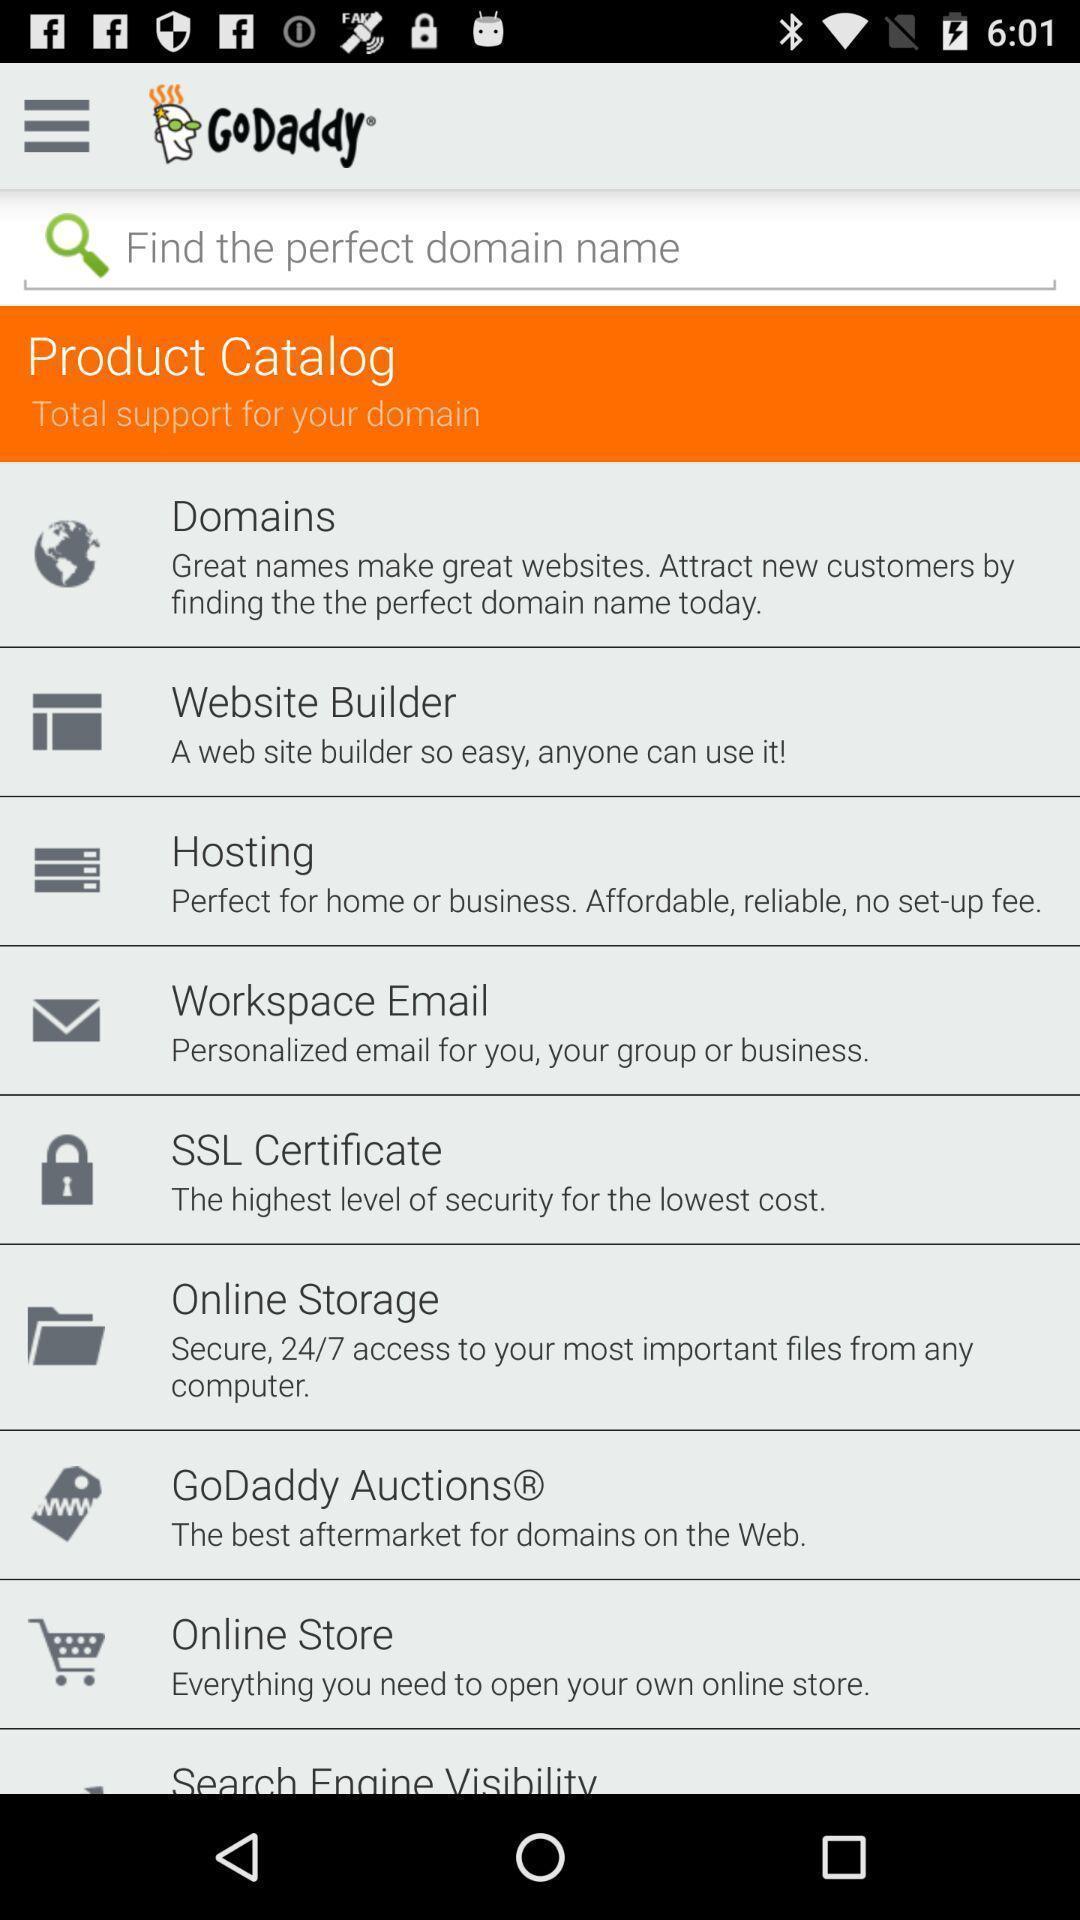Summarize the main components in this picture. Window displaying all the domains. 